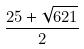Convert formula to latex. <formula><loc_0><loc_0><loc_500><loc_500>\frac { 2 5 + \sqrt { 6 2 1 } } { 2 }</formula> 